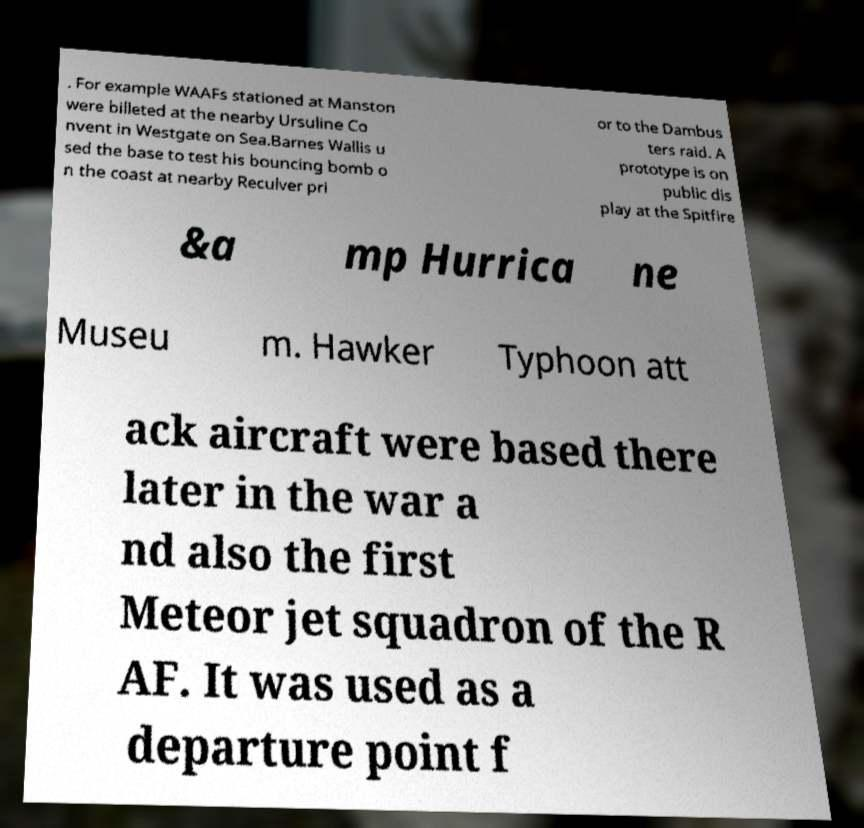There's text embedded in this image that I need extracted. Can you transcribe it verbatim? . For example WAAFs stationed at Manston were billeted at the nearby Ursuline Co nvent in Westgate on Sea.Barnes Wallis u sed the base to test his bouncing bomb o n the coast at nearby Reculver pri or to the Dambus ters raid. A prototype is on public dis play at the Spitfire &a mp Hurrica ne Museu m. Hawker Typhoon att ack aircraft were based there later in the war a nd also the first Meteor jet squadron of the R AF. It was used as a departure point f 